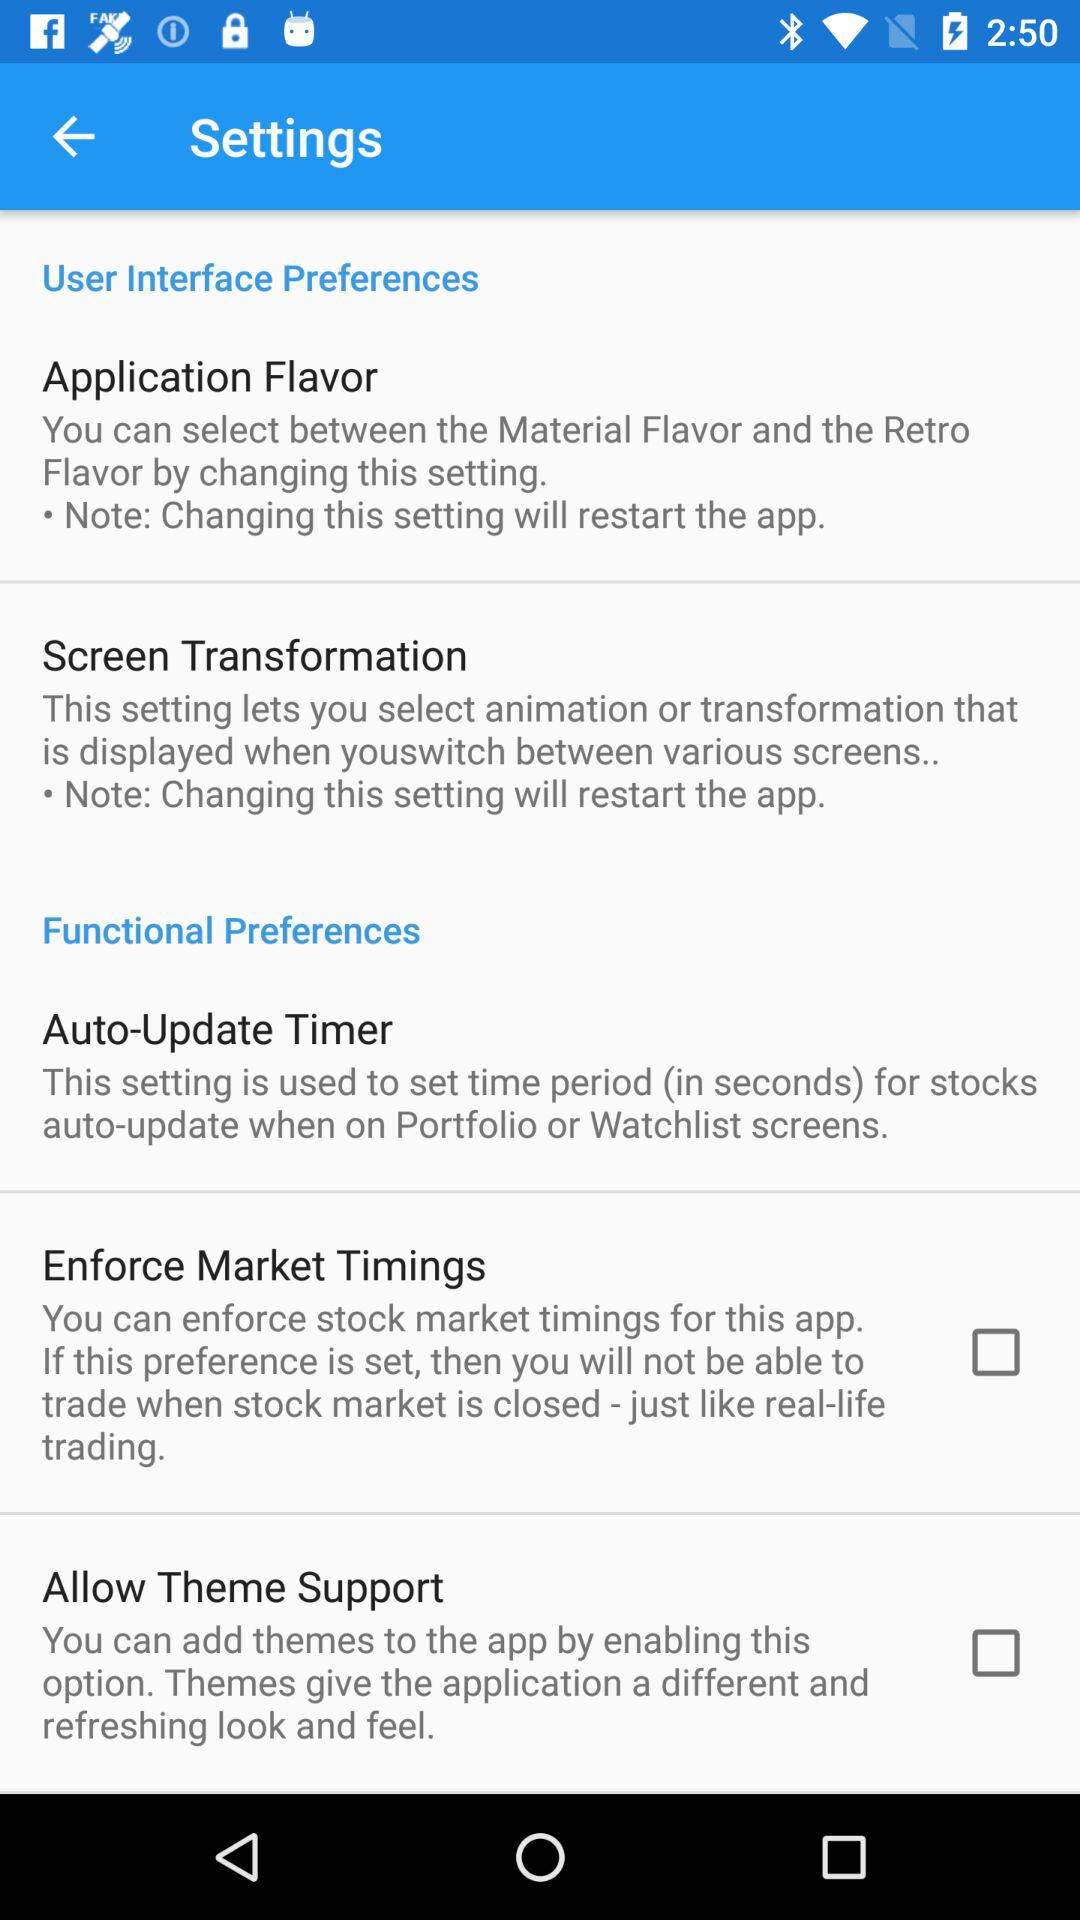What are the application's flavor preferences?
When the provided information is insufficient, respond with <no answer>. <no answer> 